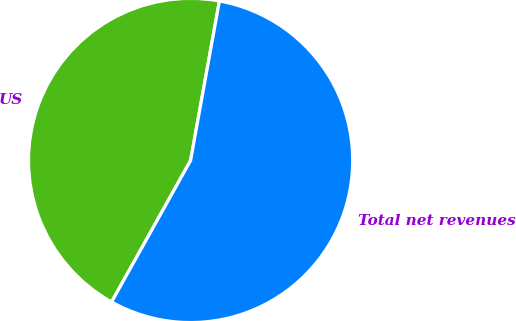Convert chart to OTSL. <chart><loc_0><loc_0><loc_500><loc_500><pie_chart><fcel>US<fcel>Total net revenues<nl><fcel>44.74%<fcel>55.26%<nl></chart> 